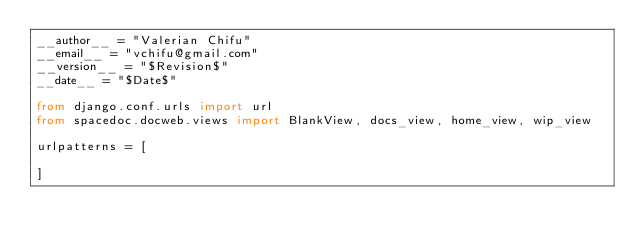<code> <loc_0><loc_0><loc_500><loc_500><_Python_>__author__ = "Valerian Chifu"
__email__ = "vchifu@gmail.com"
__version__ = "$Revision$"
__date__ = "$Date$"

from django.conf.urls import url
from spacedoc.docweb.views import BlankView, docs_view, home_view, wip_view

urlpatterns = [

]</code> 